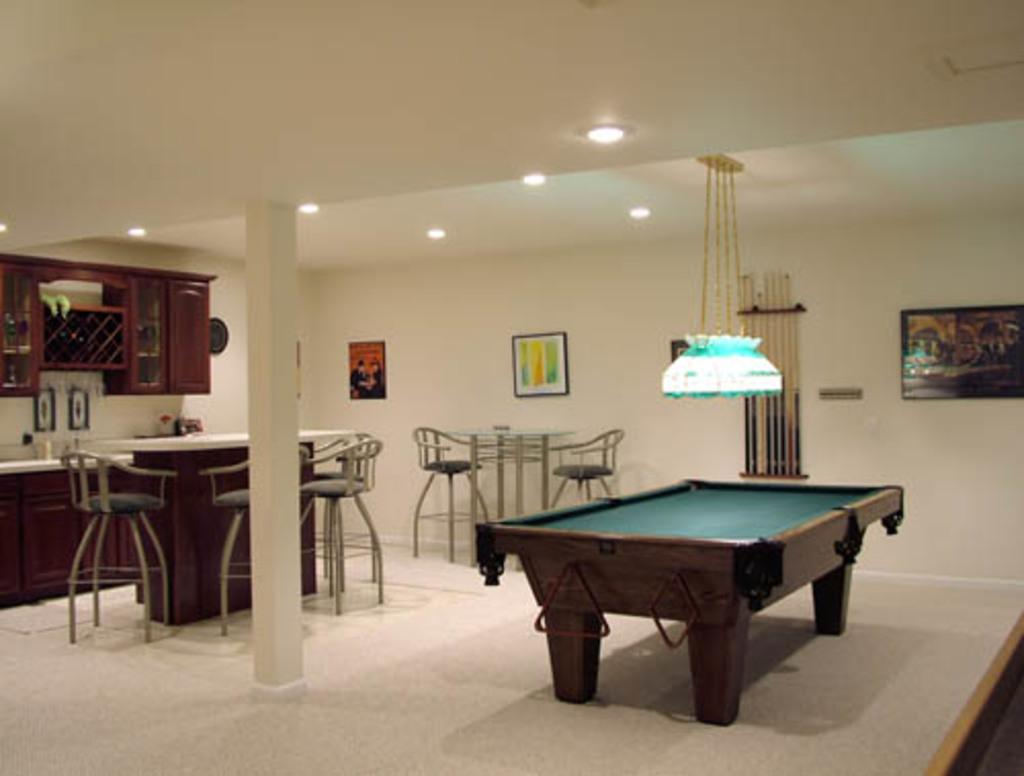What type of furniture is present in the image? There are chairs and a table in the image. What type of game can be played on the table in the image? There is a snooker table in the image, which is used for playing snooker. What can be seen on the walls in the image? There are frames on the wall in the image. How many lips are visible on the snooker table in the image? There are no lips visible on the snooker table in the image, as it is a game table and not related to lips. 